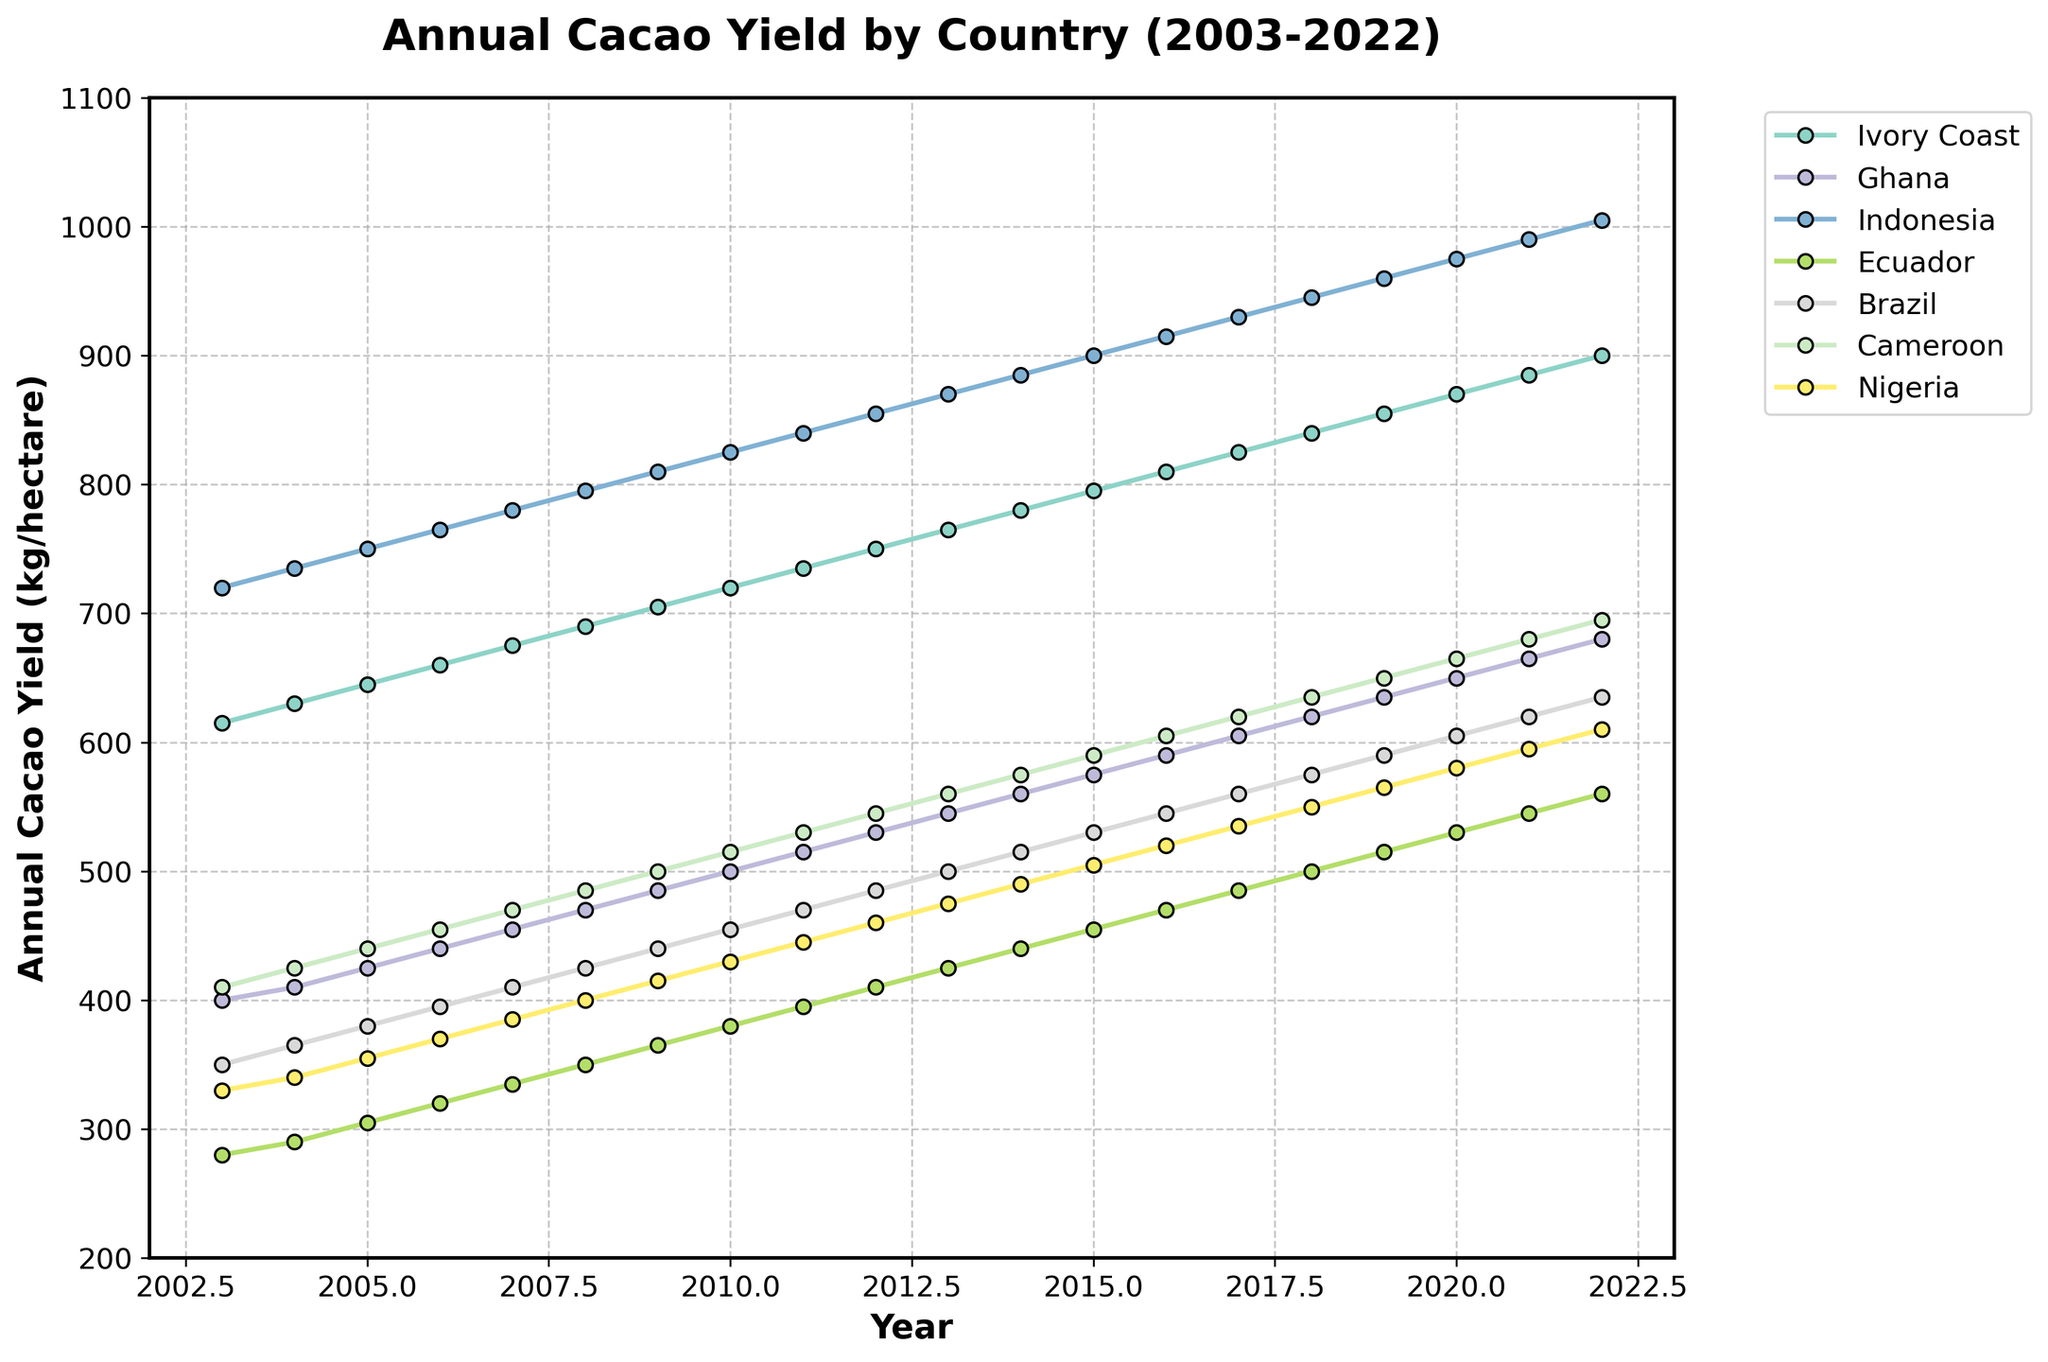What trend do you observe in annual cacao yield for Ivory Coast over the 20 years? Look at the line representing Ivory Coast from 2003 to 2022. The yield consistently increases over this period, from 615 kg/hectare in 2003 to 900 kg/hectare in 2022.
Answer: The yield consistently increases Which country had the highest cacao yield in 2015? By observing the 2015 data points, Indonesia has the highest yield at 900 kg/hectare.
Answer: Indonesia How does the cacao yield growth rate in Ecuador compare to that in Brazil from 2003 to 2022? From the graph, Ecuador's yield grows from 280 to 560 kg/hectare, an increase of 280 kg/hectare. Brazil's yield grows from 350 to 635 kg/hectare, an increase of 285 kg/hectare. Therefore, Brazil's growth rate is slightly higher.
Answer: Brazil's growth rate is slightly higher What is the average cacao yield for Ghana over the 20 years? Add the yields for Ghana for each year from 2003 to 2022 and divide by 20: (400 + 410 + 425 + ... + 665 + 680)/20. The sum is 11775, dividing by 20, the average is 588.75 kg/hectare.
Answer: 588.75 kg/hectare Which countries showed consistent growth in cacao yield every year? Observing the trends, Ivory Coast, Indonesia, Ecuador, Brazil, and Ghana show a steady increase in yield each year.
Answer: Ivory Coast, Indonesia, Ecuador, Brazil, Ghana In which year did Nigeria surpass Cameroon in cacao yield? Follow the lines representing Nigeria and Cameroon. Nigeria's yield surpasses Cameroon's sometime between 2020 and 2021, with Nigeria's yield reaching 595 kg/hectare in 2021 compared to Cameroon's 680 kg/hectare.
Answer: 2021 What is the difference in cacao yield between Ivory Coast and Ivory Coast in 2003 and 2022? Subtract the 2003 yield from the 2022 yield for Ivory Coast: 900 - 615 = 285.
Answer: 285 kg/hectare Which country's yield was the most improved over the 20 years? The increase for each country from 2003 to 2022: Ivory Coast (285), Ghana (280), Indonesia (285), Ecuador (280), Brazil (285), Cameroon (285), Nigeria (280). All countries, mainly Brazil, Indonesia, and Cameroon, increased by 285 kg/hectare.
Answer: Brazil, Indonesia, Cameroon What was the median yield for Ecuador over the 20 years? Arrange Ecuador's yields in ascending order and select the middle value. (280, 290, 305, 320, 335, 350, 365, 380, 395, 410, 425, 440, 455, 470, 485, 500, 515, 530, 545, 560). The median value is the 10th and 11th average values: (410 + 425)/2 = 417.5 kg/hectare.
Answer: 417.5 kg/hectare 